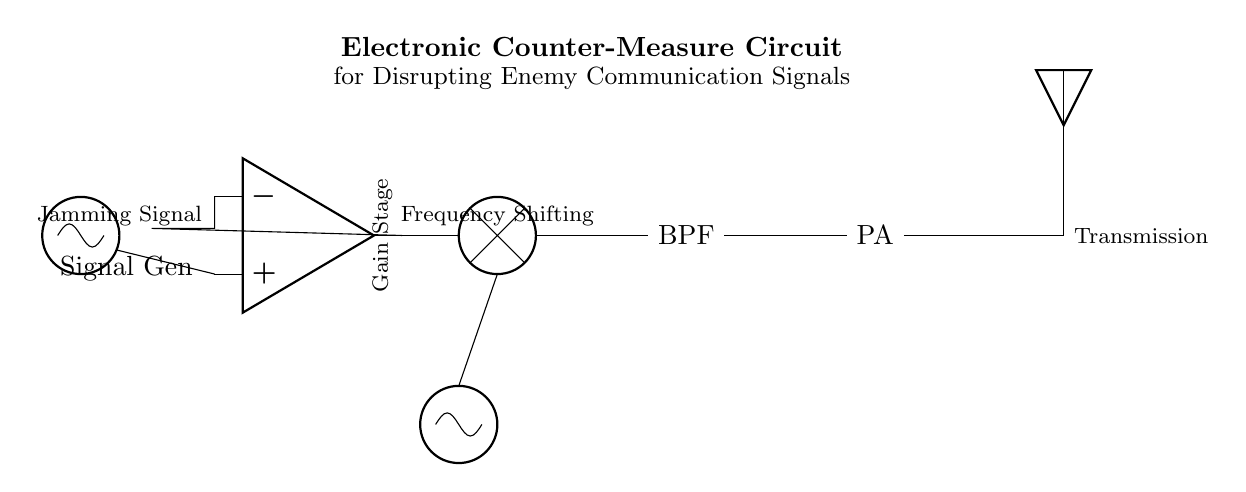What component generates the jamming signal? The circuit diagram shows an oscillator labeled "Signal Gen" at the left side, which generates the signal to disrupt communication.
Answer: Signal Generator What is the purpose of the band-pass filter? The band-pass filter is designed to allow only certain frequencies to pass through while attenuating others, which helps in refining the jamming signal to just the frequencies of interest.
Answer: Frequency refinement Which component increases the power of the signal before transmission? The power amplifier, labeled "PA", is responsible for boosting the signal's power to ensure it is strong enough for effective transmission through the antenna.
Answer: Power Amplifier What type of circuit is this designed for? This circuit is specifically tailored as an electronic counter-measure circuit for disrupting enemy communication signals, focusing on jamming capabilities.
Answer: Electronic Counter-Measure What connects the local oscillator to the mixer? A direct connection line from the local oscillator node to the south terminal of the mixer represents this connection, suggesting a necessary interaction for the frequency shifting process.
Answer: Direct connection 